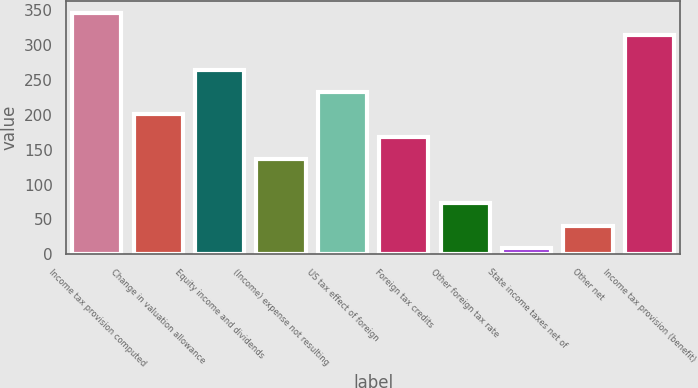Convert chart to OTSL. <chart><loc_0><loc_0><loc_500><loc_500><bar_chart><fcel>Income tax provision computed<fcel>Change in valuation allowance<fcel>Equity income and dividends<fcel>(Income) expense not resulting<fcel>US tax effect of foreign<fcel>Foreign tax credits<fcel>Other foreign tax rate<fcel>State income taxes net of<fcel>Other net<fcel>Income tax provision (benefit)<nl><fcel>346<fcel>201<fcel>265<fcel>137<fcel>233<fcel>169<fcel>73<fcel>9<fcel>41<fcel>314<nl></chart> 